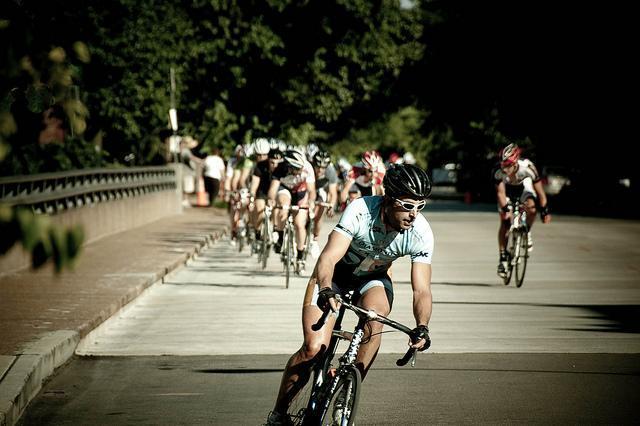How many pedestrians are there?
Give a very brief answer. 2. How many people are there?
Give a very brief answer. 3. 